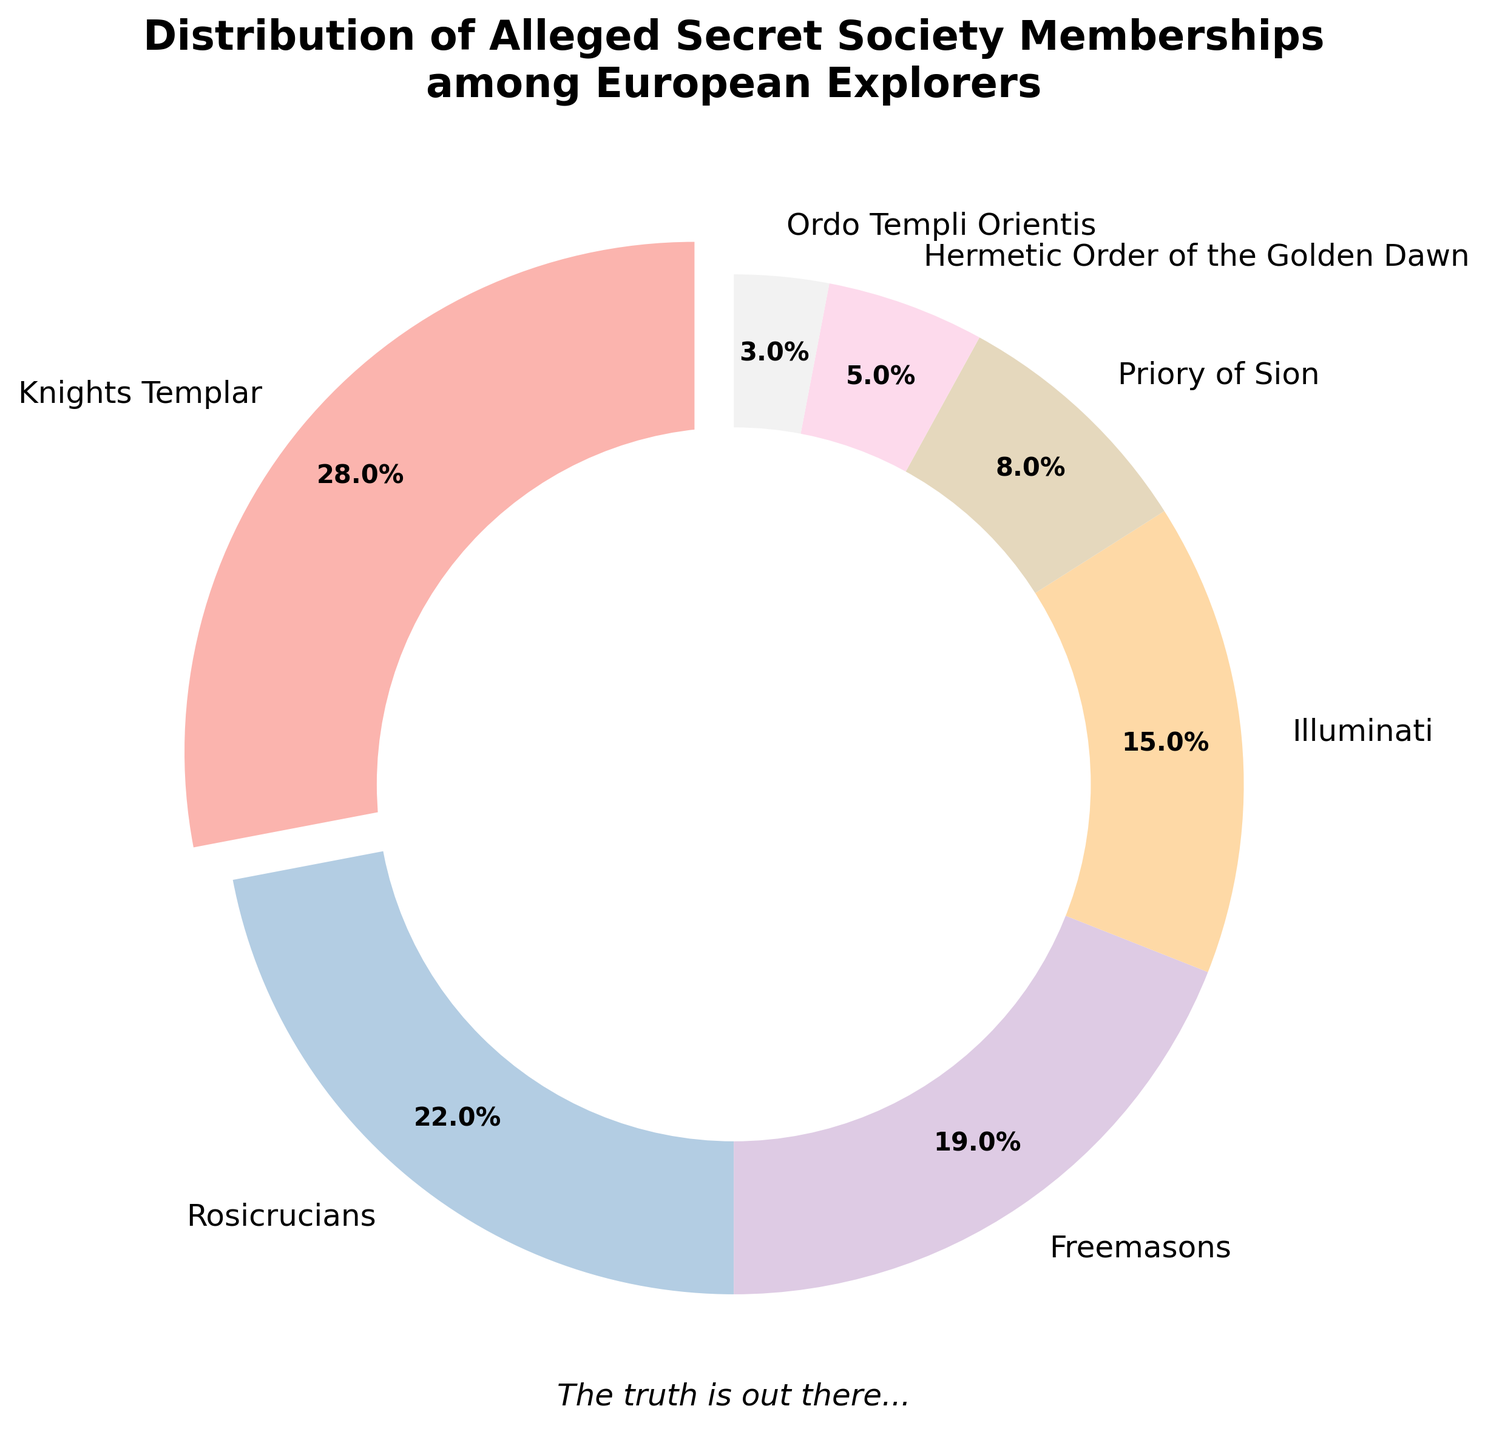What is the combined percentage of European explorers allegedly linked to the Knights Templar and the Rosicrucians? The figure shows the Knights Templar at 28% and the Rosicrucians at 22%. Adding these percentages gives us 28 + 22 = 50%.
Answer: 50% Which secret society has the smallest alleged membership among European explorers? The figure shows the Hermetic Order of the Golden Dawn and Ordo Templi Orientis as the smallest, with percentages of 5% and 3%, respectively. The Ordo Templi Orientis has the smaller percentage.
Answer: Ordo Templi Orientis How much higher is the percentage of Freemasons compared to the Priory of Sion? The figure shows the Freemasons at 19% and the Priory of Sion at 8%. The difference between them is 19 - 8 = 11%.
Answer: 11% What is the combined percentage of secret society memberships for the Illuminati, Priory of Sion, and Hermetic Order of the Golden Dawn? The figure shows the Illuminati at 15%, the Priory of Sion at 8%, and the Hermetic Order of the Golden Dawn at 5%. Adding these percentages gives us 15 + 8 + 5 = 28%.
Answer: 28% Which secret society segment is highlighted in the pie chart? The pie chart visually highlights the segment with the largest percentage by "exploding" it away from the center. The Knights Templar segment is exploded, indicating it has the highest percentage.
Answer: Knights Templar Compare the combined percentage of the Knights Templar and Freemasons to that of the Rosicrucians and Illuminati. Which is higher? The figure shows the Knights Templar at 28% and Freemasons at 19%, giving a combined percentage of 28 + 19 = 47%. The Rosicrucians are at 22% and the Illuminati at 15%, with a combined percentage of 22 + 15 = 37%. Therefore, the combined percentage of the Knights Templar and Freemasons is higher.
Answer: Knights Templar and Freemasons By how much does the percentage of the Rosicrucians exceed that of the Priory of Sion? The figure shows the Rosicrucians at 22% and the Priory of Sion at 8%. The difference between them is 22 - 8 = 14%.
Answer: 14% What color represents the Illuminati in the pie chart? The chart uses a color palette for the different societies. The segment labeled Illuminati can be directly observed in the pie chart, but without the figure, it’s impossible to definitively state its color here.
Answer: Unknown What portion of the pie chart is allocated to societies with less than 10% membership each? The societies under 10% are the Priory of Sion (8%), Hermetic Order of the Golden Dawn (5%), and Ordo Templi Orientis (3%). Adding these gives 8 + 5 + 3 = 16%.
Answer: 16% 